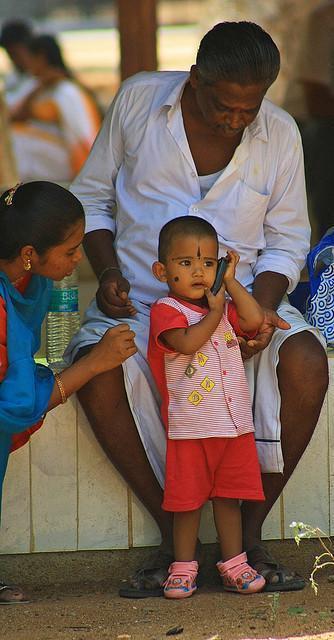What type of phone is being used?
Answer the question by selecting the correct answer among the 4 following choices.
Options: Cellular, pay, landline, rotary. Cellular. 